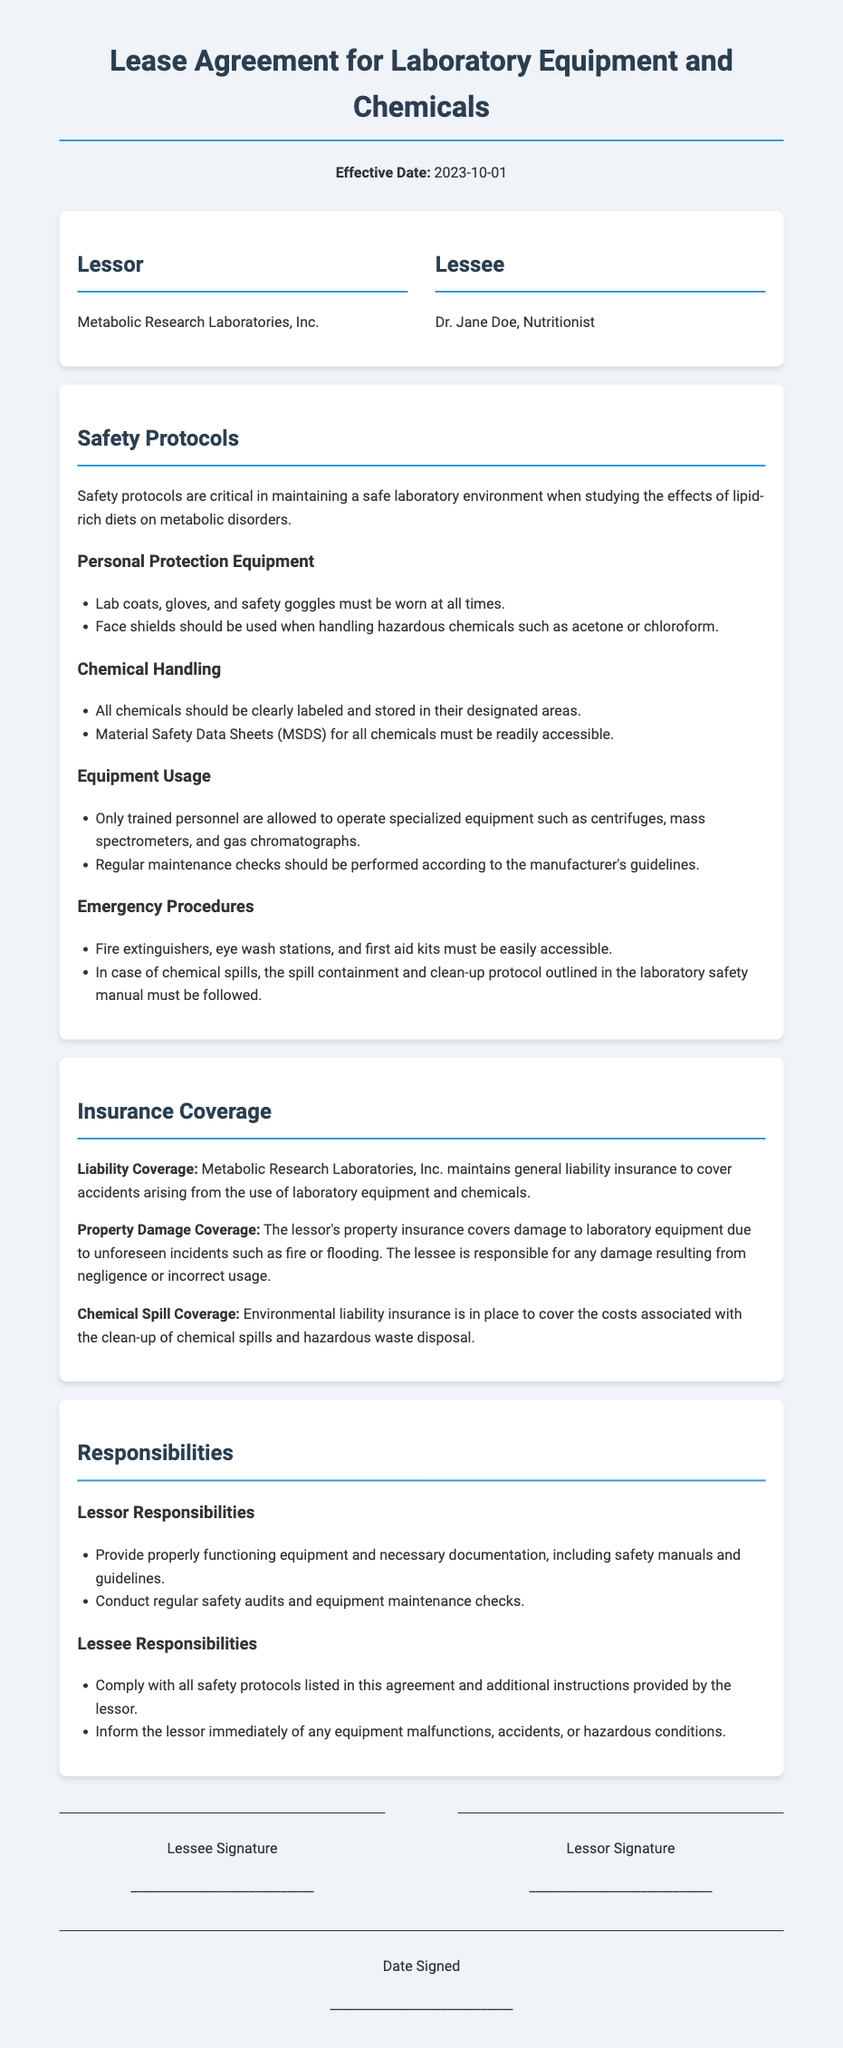What is the effective date of the lease agreement? The effective date is stated at the beginning of the document.
Answer: 2023-10-01 Who is the lessee in this agreement? The lessee is identified in the parties section of the document.
Answer: Dr. Jane Doe, Nutritionist What must be worn at all times in the lab? The safety protocols outline the required personal protection equipment.
Answer: Lab coats, gloves, and safety goggles What type of insurance covers damage to laboratory equipment? The insurance coverage section specifies the type of coverage relevant to equipment damage.
Answer: Property Damage Coverage What must be accessible for all chemicals used in the lab? The safety protocols detail the necessary documentation for chemical handling.
Answer: Material Safety Data Sheets (MSDS) Who is responsible for equipment maintenance checks? The responsibilities section outlines responsibilities for both the lessor and lessee.
Answer: Lessor What type of insurance is in place for chemical spills? The document specifies the type of coverage related to chemical spills and environmental hazards.
Answer: Chemical Spill Coverage What must be used when handling hazardous chemicals? The safety protocols specify the safety equipment required when dealing with hazardous substances.
Answer: Face shields What are the consequences of negligence in using the equipment? The insurance coverage section highlights the responsibilities of the lessee regarding usage.
Answer: Lessee is responsible for any damage resulting from negligence or incorrect usage 